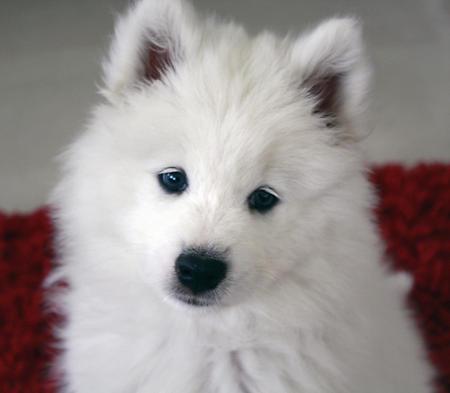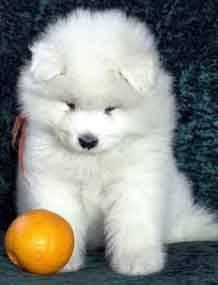The first image is the image on the left, the second image is the image on the right. Given the left and right images, does the statement "The right image contains at least one white dog with its tongue exposed." hold true? Answer yes or no. No. The first image is the image on the left, the second image is the image on the right. Assess this claim about the two images: "The combined images include two white dogs with smiling opened mouths showing pink tongues.". Correct or not? Answer yes or no. No. 